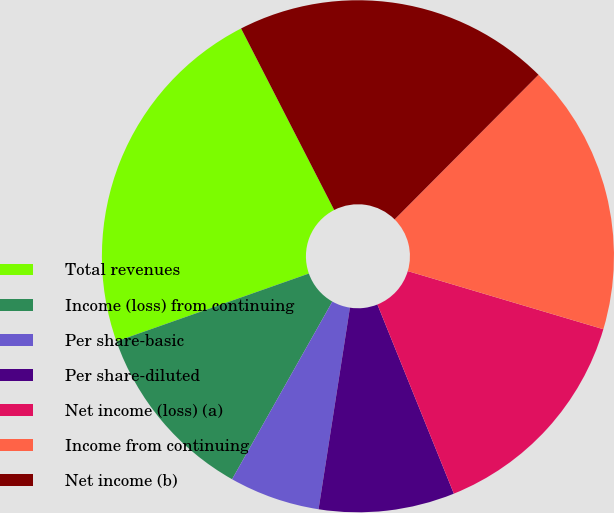Convert chart to OTSL. <chart><loc_0><loc_0><loc_500><loc_500><pie_chart><fcel>Total revenues<fcel>Income (loss) from continuing<fcel>Per share-basic<fcel>Per share-diluted<fcel>Net income (loss) (a)<fcel>Income from continuing<fcel>Net income (b)<nl><fcel>22.85%<fcel>11.43%<fcel>5.72%<fcel>8.57%<fcel>14.29%<fcel>17.14%<fcel>20.0%<nl></chart> 